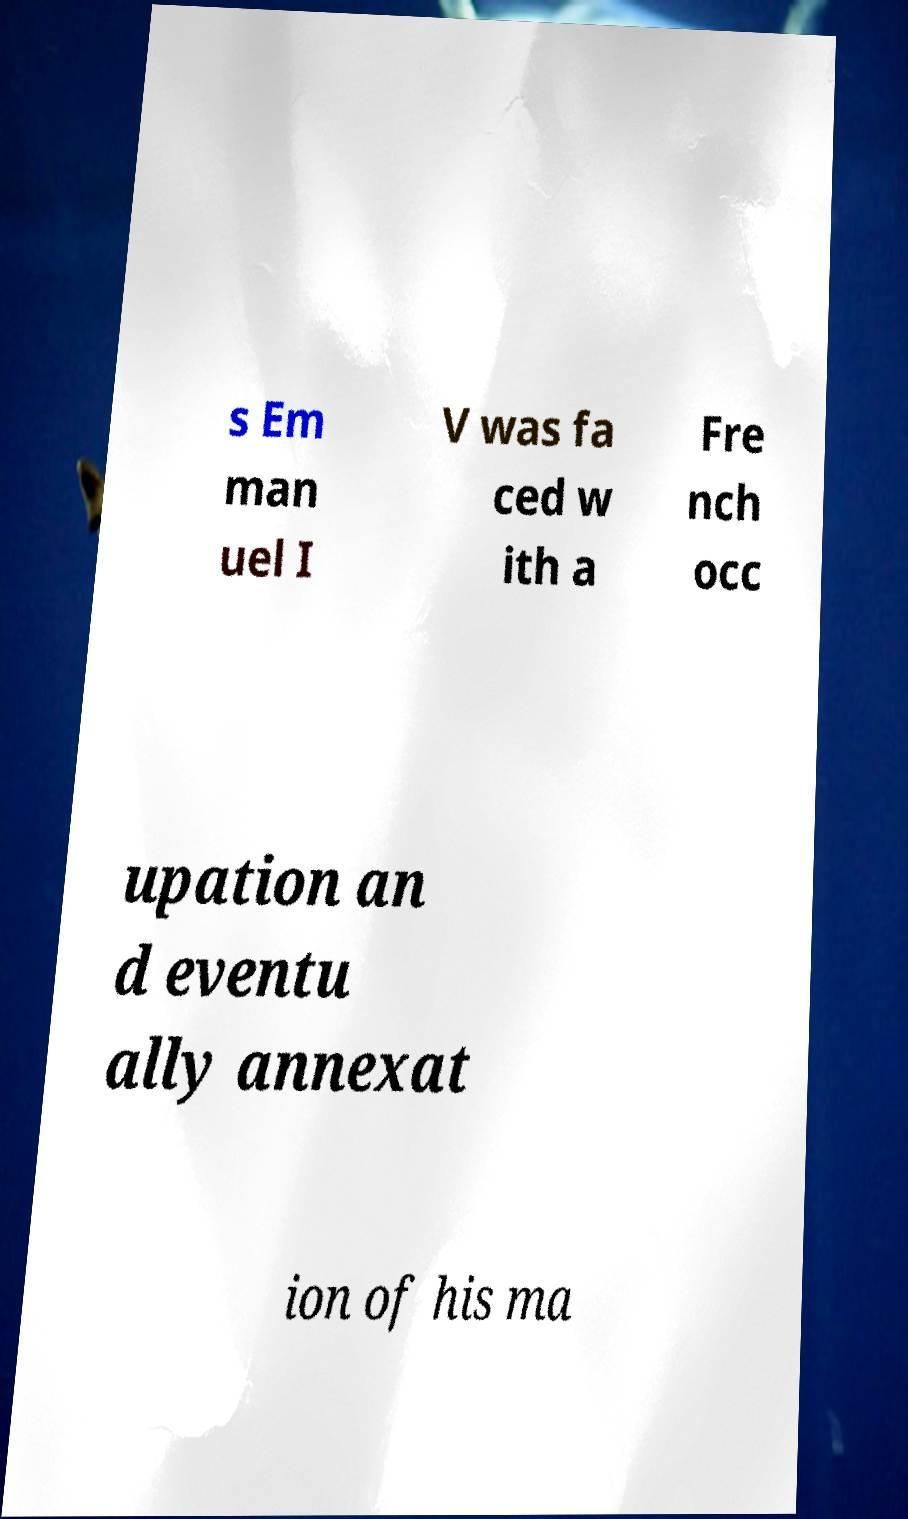What messages or text are displayed in this image? I need them in a readable, typed format. s Em man uel I V was fa ced w ith a Fre nch occ upation an d eventu ally annexat ion of his ma 